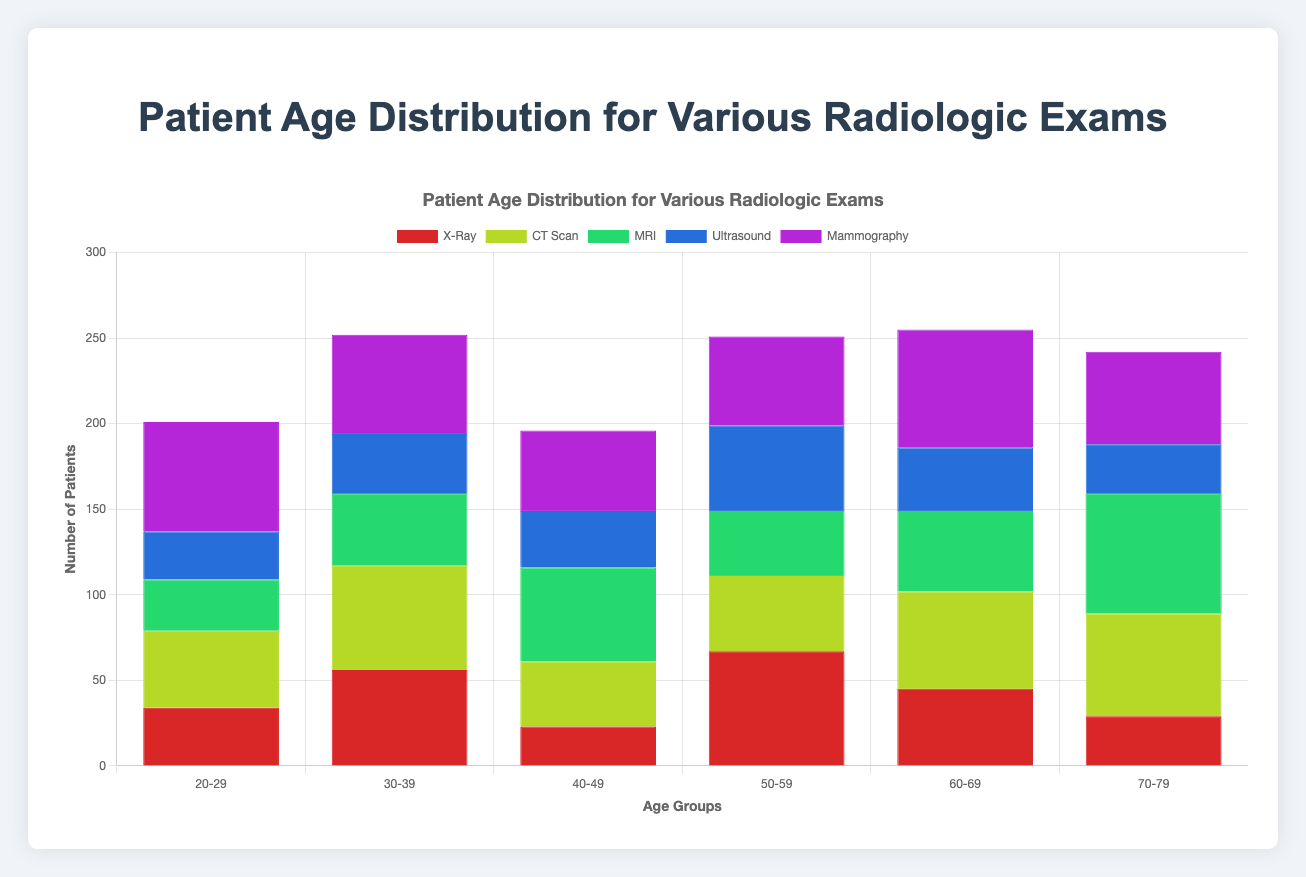What is the title of the chart? The title of the chart is usually displayed at the top and provides a summary of what the chart is about. In this case, it's "Patient Age Distribution for Various Radiologic Exams".
Answer: Patient Age Distribution for Various Radiologic Exams Which age group has the highest number of patients undergoing Mammography? To find this, look at the section of the bar chart corresponding to Mammography. The age group with the highest bar segment for this exam type will be the one with the highest number of patients.
Answer: 60-69 How many patients aged between 30-39 underwent CT Scans? Look at the bar chart section labeled '30-39' for the CT Scan dataset. The bar’s height indicates the number of patients in this age group.
Answer: 2 Which radiologic exam has the most evenly distributed patient age groups? To answer this, observe the distribution patterns for each exam type. The one with the most even distribution will have bar segments of almost equal heights across all age groups.
Answer: MRI What is the total number of patients who underwent X-Rays? Sum the heights of the bars associated with the X-Ray category across all age groups.
Answer: 20 Which age group has the smallest number of patients for Ultrasound? Look at the sections of the bar chart representing Ultrasound and compare the heights of the bar segments across age groups. The smallest bar indicates the smallest number.
Answer: 70-79 Compare and find out which radiologic exam has the youngest average patient age. For each radiologic exam, calculate the average age by using the number of patients in each age group, multiply by the mid-point of the age group, then divide by the total number of patients in that exam. Compare these averages to find the lowest one. The mid points of the age groups are: (20-29 → 24.5), (30-39 → 34.5), (40-49 → 44.5), (50-59 → 54.5), (60-69 → 64.5), (70-79 → 74.5). MRI has more younger patients.
Answer: MRI What's the average age of patients undergoing Mammography? Calculate the weighted average age using the patient age data for Mammography. Sum the ages weighted by the number of patients in that age group and divide by the total number of patients. Age group midpoints:  24.5, 34.5, 44.5, 54.5, 64.5, 74.5. For Mammography, the data is more inclined toward older ages.
Answer: 55-65 Which age group is most common across all radiologic exams? Sum the number of patients for each age group across all radiologic exams and then compare these sums. The group with the highest total is the most common age group.
Answer: 40-49 By how much does the number of CT Scan patients aged 60-69 exceed those for X-Rays in the same age group? First, identify the number of patients for CT Scan and X-Ray in the '60-69' age group. Subtract the number of X-Ray patients from the number of CT Scan patients in this age group to get the difference.
Answer: 6 Which exam type has the greatest number of patients aged 70-79? Assess the bars in the '70-79' age group for each exam type, and identify the one with the tallest bar. That indicates the highest number of patients for that type.
Answer: X-Ray What's the total number of patients aged 50-59 across all exam types? Sum the patients listed in the '50-59' bar sections for all exam types. Add up the counts seen in this age category from each type of exam.
Answer: 16 